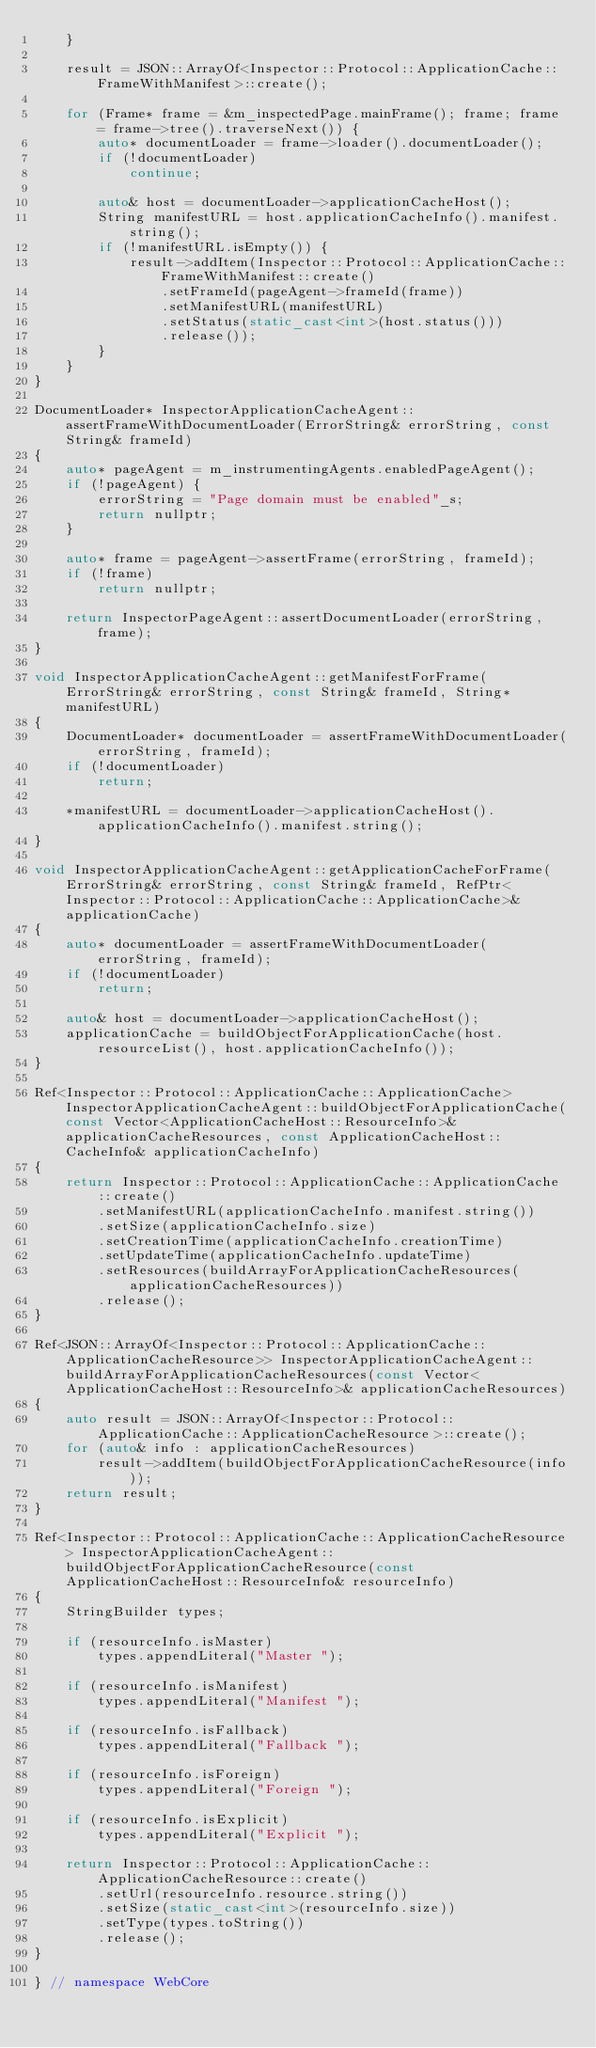<code> <loc_0><loc_0><loc_500><loc_500><_C++_>    }

    result = JSON::ArrayOf<Inspector::Protocol::ApplicationCache::FrameWithManifest>::create();

    for (Frame* frame = &m_inspectedPage.mainFrame(); frame; frame = frame->tree().traverseNext()) {
        auto* documentLoader = frame->loader().documentLoader();
        if (!documentLoader)
            continue;

        auto& host = documentLoader->applicationCacheHost();
        String manifestURL = host.applicationCacheInfo().manifest.string();
        if (!manifestURL.isEmpty()) {
            result->addItem(Inspector::Protocol::ApplicationCache::FrameWithManifest::create()
                .setFrameId(pageAgent->frameId(frame))
                .setManifestURL(manifestURL)
                .setStatus(static_cast<int>(host.status()))
                .release());
        }
    }
}

DocumentLoader* InspectorApplicationCacheAgent::assertFrameWithDocumentLoader(ErrorString& errorString, const String& frameId)
{
    auto* pageAgent = m_instrumentingAgents.enabledPageAgent();
    if (!pageAgent) {
        errorString = "Page domain must be enabled"_s;
        return nullptr;
    }

    auto* frame = pageAgent->assertFrame(errorString, frameId);
    if (!frame)
        return nullptr;

    return InspectorPageAgent::assertDocumentLoader(errorString, frame);
}

void InspectorApplicationCacheAgent::getManifestForFrame(ErrorString& errorString, const String& frameId, String* manifestURL)
{
    DocumentLoader* documentLoader = assertFrameWithDocumentLoader(errorString, frameId);
    if (!documentLoader)
        return;

    *manifestURL = documentLoader->applicationCacheHost().applicationCacheInfo().manifest.string();
}

void InspectorApplicationCacheAgent::getApplicationCacheForFrame(ErrorString& errorString, const String& frameId, RefPtr<Inspector::Protocol::ApplicationCache::ApplicationCache>& applicationCache)
{
    auto* documentLoader = assertFrameWithDocumentLoader(errorString, frameId);
    if (!documentLoader)
        return;

    auto& host = documentLoader->applicationCacheHost();
    applicationCache = buildObjectForApplicationCache(host.resourceList(), host.applicationCacheInfo());
}

Ref<Inspector::Protocol::ApplicationCache::ApplicationCache> InspectorApplicationCacheAgent::buildObjectForApplicationCache(const Vector<ApplicationCacheHost::ResourceInfo>& applicationCacheResources, const ApplicationCacheHost::CacheInfo& applicationCacheInfo)
{
    return Inspector::Protocol::ApplicationCache::ApplicationCache::create()
        .setManifestURL(applicationCacheInfo.manifest.string())
        .setSize(applicationCacheInfo.size)
        .setCreationTime(applicationCacheInfo.creationTime)
        .setUpdateTime(applicationCacheInfo.updateTime)
        .setResources(buildArrayForApplicationCacheResources(applicationCacheResources))
        .release();
}

Ref<JSON::ArrayOf<Inspector::Protocol::ApplicationCache::ApplicationCacheResource>> InspectorApplicationCacheAgent::buildArrayForApplicationCacheResources(const Vector<ApplicationCacheHost::ResourceInfo>& applicationCacheResources)
{
    auto result = JSON::ArrayOf<Inspector::Protocol::ApplicationCache::ApplicationCacheResource>::create();
    for (auto& info : applicationCacheResources)
        result->addItem(buildObjectForApplicationCacheResource(info));
    return result;
}

Ref<Inspector::Protocol::ApplicationCache::ApplicationCacheResource> InspectorApplicationCacheAgent::buildObjectForApplicationCacheResource(const ApplicationCacheHost::ResourceInfo& resourceInfo)
{
    StringBuilder types;

    if (resourceInfo.isMaster)
        types.appendLiteral("Master ");

    if (resourceInfo.isManifest)
        types.appendLiteral("Manifest ");

    if (resourceInfo.isFallback)
        types.appendLiteral("Fallback ");

    if (resourceInfo.isForeign)
        types.appendLiteral("Foreign ");

    if (resourceInfo.isExplicit)
        types.appendLiteral("Explicit ");

    return Inspector::Protocol::ApplicationCache::ApplicationCacheResource::create()
        .setUrl(resourceInfo.resource.string())
        .setSize(static_cast<int>(resourceInfo.size))
        .setType(types.toString())
        .release();
}

} // namespace WebCore
</code> 